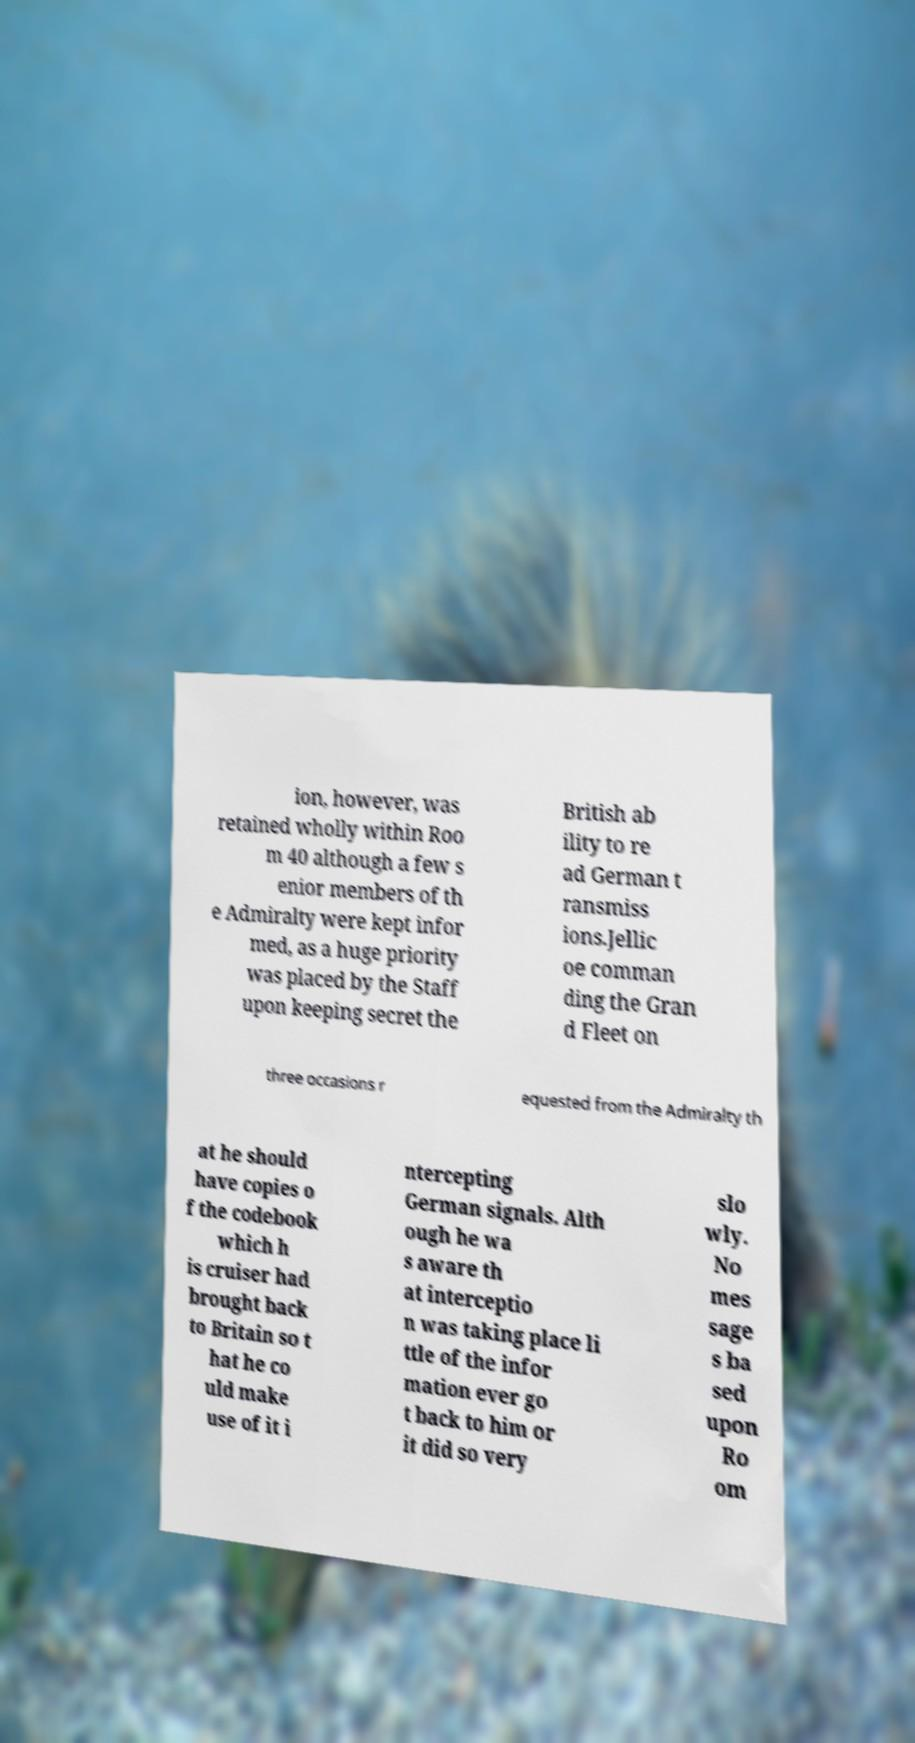Could you assist in decoding the text presented in this image and type it out clearly? ion, however, was retained wholly within Roo m 40 although a few s enior members of th e Admiralty were kept infor med, as a huge priority was placed by the Staff upon keeping secret the British ab ility to re ad German t ransmiss ions.Jellic oe comman ding the Gran d Fleet on three occasions r equested from the Admiralty th at he should have copies o f the codebook which h is cruiser had brought back to Britain so t hat he co uld make use of it i ntercepting German signals. Alth ough he wa s aware th at interceptio n was taking place li ttle of the infor mation ever go t back to him or it did so very slo wly. No mes sage s ba sed upon Ro om 